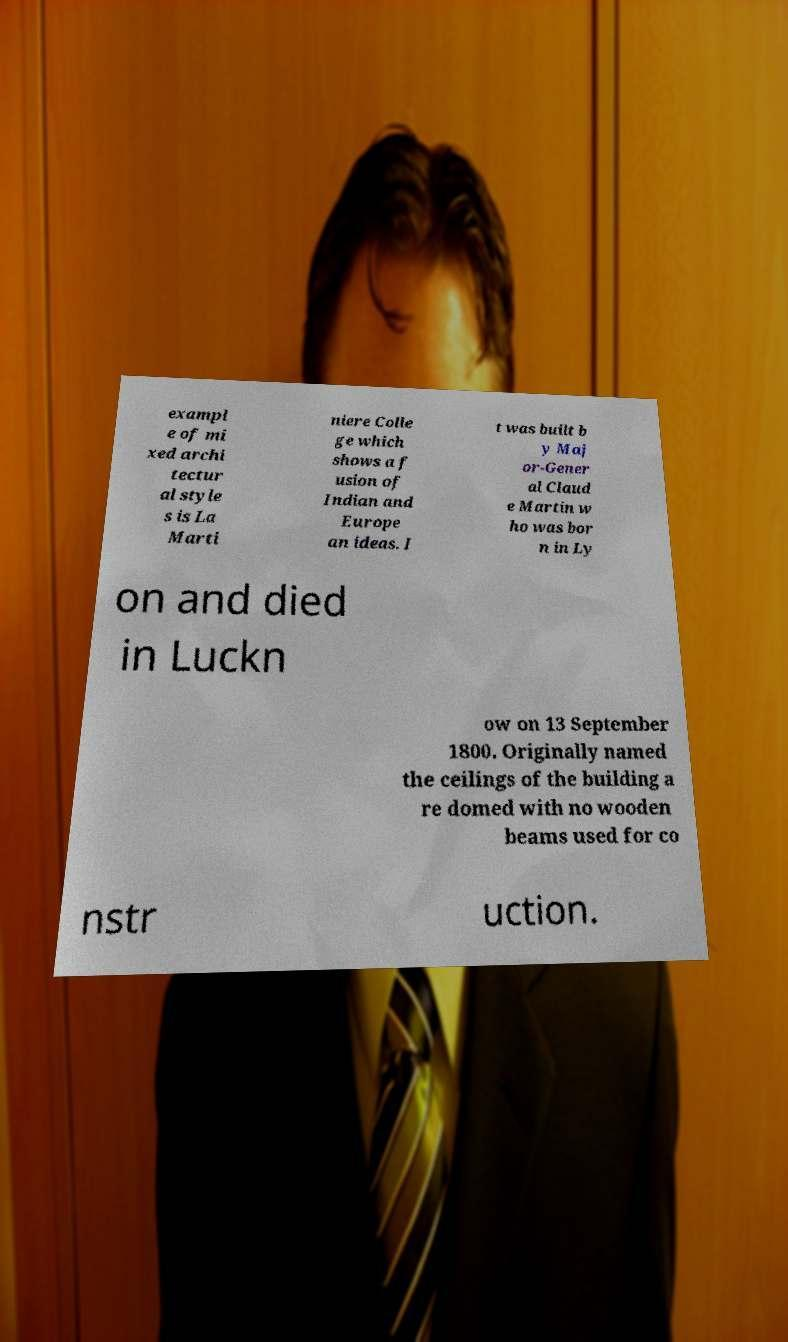What messages or text are displayed in this image? I need them in a readable, typed format. exampl e of mi xed archi tectur al style s is La Marti niere Colle ge which shows a f usion of Indian and Europe an ideas. I t was built b y Maj or-Gener al Claud e Martin w ho was bor n in Ly on and died in Luckn ow on 13 September 1800. Originally named the ceilings of the building a re domed with no wooden beams used for co nstr uction. 